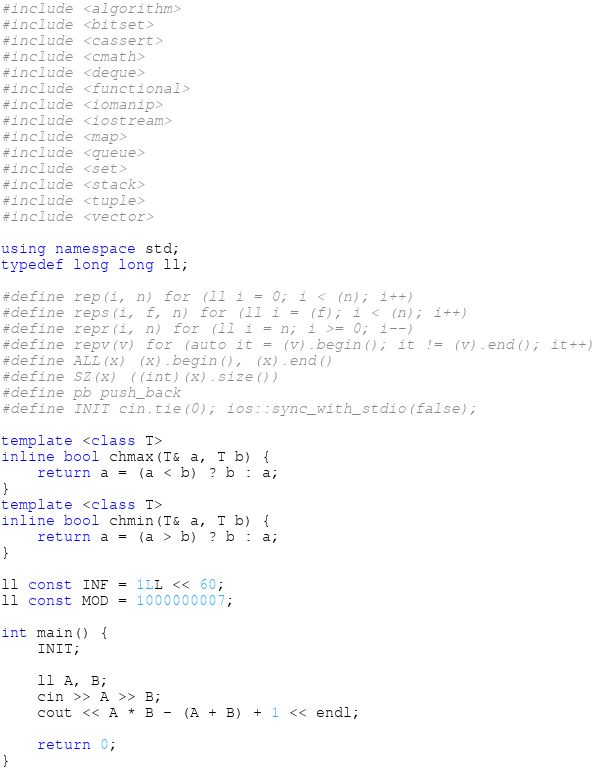<code> <loc_0><loc_0><loc_500><loc_500><_C++_>#include <algorithm>
#include <bitset>
#include <cassert>
#include <cmath>
#include <deque>
#include <functional>
#include <iomanip>
#include <iostream>
#include <map>
#include <queue>
#include <set>
#include <stack>
#include <tuple>
#include <vector>

using namespace std;
typedef long long ll;

#define rep(i, n) for (ll i = 0; i < (n); i++)
#define reps(i, f, n) for (ll i = (f); i < (n); i++)
#define repr(i, n) for (ll i = n; i >= 0; i--)
#define repv(v) for (auto it = (v).begin(); it != (v).end(); it++)
#define ALL(x) (x).begin(), (x).end()
#define SZ(x) ((int)(x).size())
#define pb push_back
#define INIT cin.tie(0); ios::sync_with_stdio(false);

template <class T>
inline bool chmax(T& a, T b) {
    return a = (a < b) ? b : a;
}
template <class T>
inline bool chmin(T& a, T b) {
    return a = (a > b) ? b : a;
}

ll const INF = 1LL << 60;
ll const MOD = 1000000007;

int main() {
    INIT;

    ll A, B;
    cin >> A >> B;
    cout << A * B - (A + B) + 1 << endl;

    return 0;
}</code> 